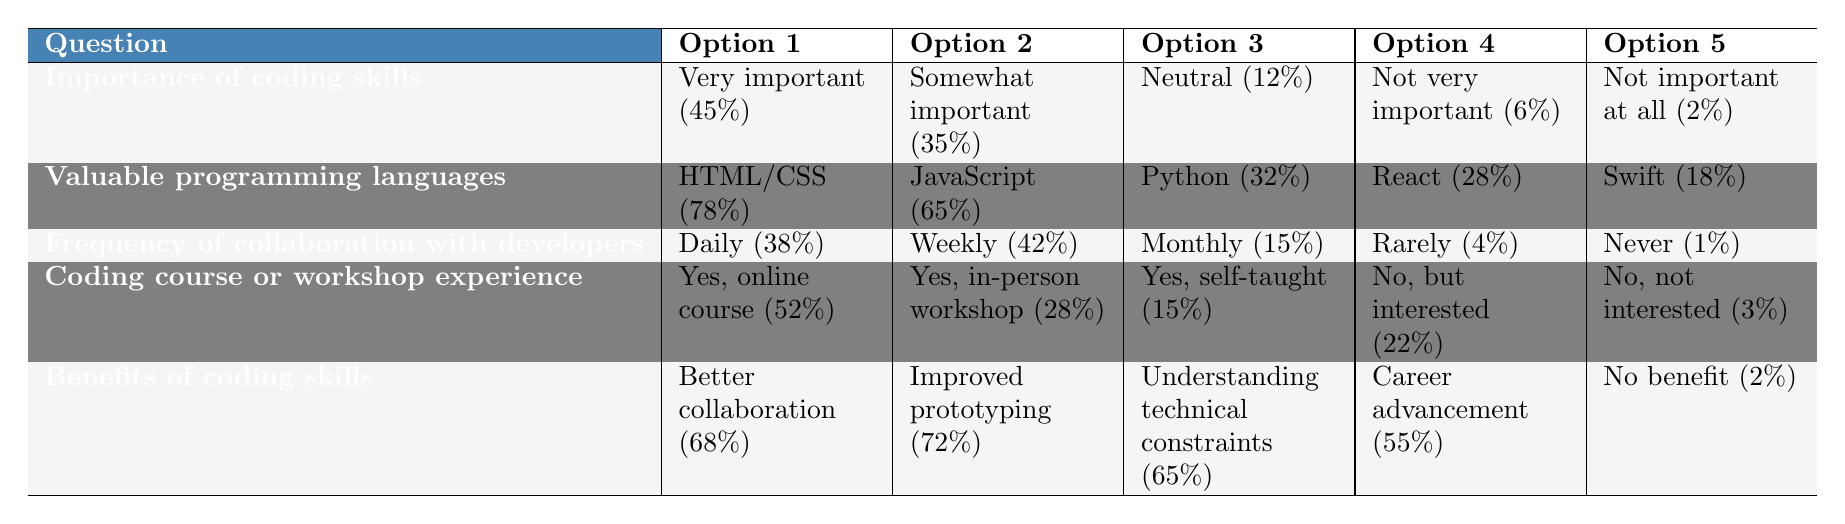What percentage of designers believe coding skills are very important for their role? The table shows that 45% of designers think coding skills are very important for UX/UI design.
Answer: 45% What are the top two programming languages designers consider most valuable to learn? According to the table, the top two languages are HTML/CSS with 78% and JavaScript with 65%.
Answer: HTML/CSS and JavaScript How many designers collaborate with developers on a weekly basis? The table indicates that 42% of respondents collaborate with developers weekly.
Answer: 42% What percentage of designers have never taken a coding course or workshop? The table states that 3% of designers have never taken a coding course or workshop and are not interested in doing so.
Answer: 3% How many designers find that coding skills would benefit them through better collaboration and improved prototyping combined? Adding the percentages for better collaboration (68%) and improved prototyping (72%) gives 140%.
Answer: 140% What is the percentage difference between designers who have taken an online course and those who are self-taught? The difference is calculated as 52% (online course) - 15% (self-taught) = 37%.
Answer: 37% Is the percentage of designers who think coding skills are not very important greater than those who think they are not important at all? Yes, the table shows 6% think not very important, which is greater than the 2% who think not important at all.
Answer: Yes How would you summarize the general attitude of designers towards the importance of coding skills? A majority of designers (80% combined) view coding skills as either very important or somewhat important, indicating a strong positive attitude.
Answer: Strong positive attitude 